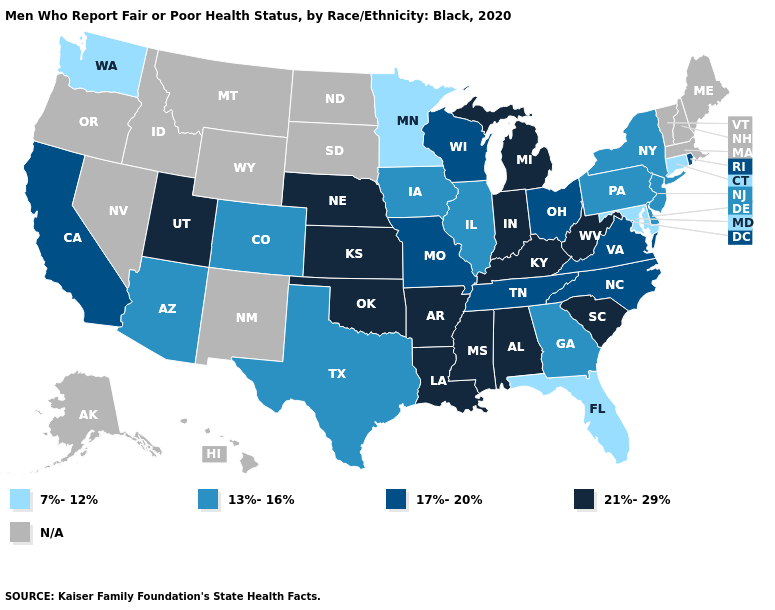Name the states that have a value in the range 13%-16%?
Write a very short answer. Arizona, Colorado, Delaware, Georgia, Illinois, Iowa, New Jersey, New York, Pennsylvania, Texas. Does the first symbol in the legend represent the smallest category?
Short answer required. Yes. Name the states that have a value in the range N/A?
Keep it brief. Alaska, Hawaii, Idaho, Maine, Massachusetts, Montana, Nevada, New Hampshire, New Mexico, North Dakota, Oregon, South Dakota, Vermont, Wyoming. Name the states that have a value in the range 17%-20%?
Be succinct. California, Missouri, North Carolina, Ohio, Rhode Island, Tennessee, Virginia, Wisconsin. Does Washington have the lowest value in the West?
Be succinct. Yes. Which states hav the highest value in the MidWest?
Short answer required. Indiana, Kansas, Michigan, Nebraska. Does Utah have the highest value in the USA?
Quick response, please. Yes. Among the states that border New York , which have the lowest value?
Short answer required. Connecticut. What is the value of Alabama?
Be succinct. 21%-29%. Does Maryland have the lowest value in the USA?
Short answer required. Yes. Does New Jersey have the lowest value in the Northeast?
Be succinct. No. How many symbols are there in the legend?
Keep it brief. 5. What is the value of South Dakota?
Answer briefly. N/A. Does Ohio have the lowest value in the USA?
Keep it brief. No. 